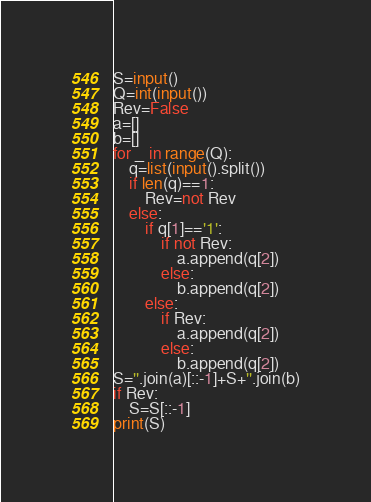<code> <loc_0><loc_0><loc_500><loc_500><_Python_>S=input()
Q=int(input())
Rev=False
a=[]
b=[]
for _ in range(Q):
    q=list(input().split())
    if len(q)==1:
        Rev=not Rev
    else:
        if q[1]=='1':
            if not Rev:
                a.append(q[2])
            else:
                b.append(q[2])
        else:
            if Rev:
                a.append(q[2])
            else:
                b.append(q[2])
S=''.join(a)[::-1]+S+''.join(b)
if Rev:
    S=S[::-1]
print(S)</code> 